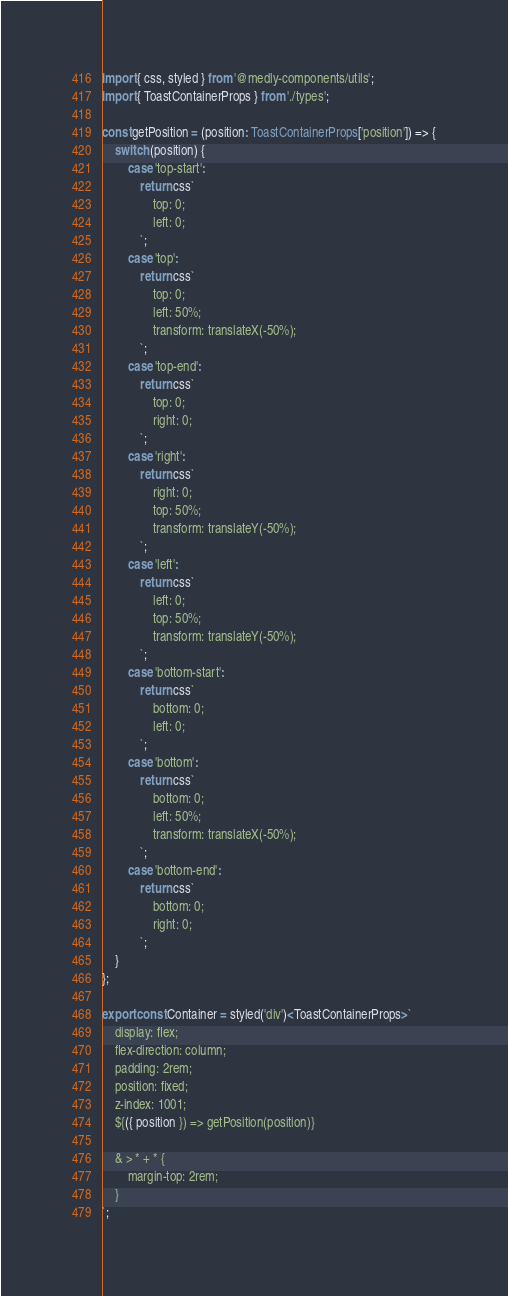<code> <loc_0><loc_0><loc_500><loc_500><_TypeScript_>import { css, styled } from '@medly-components/utils';
import { ToastContainerProps } from './types';

const getPosition = (position: ToastContainerProps['position']) => {
    switch (position) {
        case 'top-start':
            return css`
                top: 0;
                left: 0;
            `;
        case 'top':
            return css`
                top: 0;
                left: 50%;
                transform: translateX(-50%);
            `;
        case 'top-end':
            return css`
                top: 0;
                right: 0;
            `;
        case 'right':
            return css`
                right: 0;
                top: 50%;
                transform: translateY(-50%);
            `;
        case 'left':
            return css`
                left: 0;
                top: 50%;
                transform: translateY(-50%);
            `;
        case 'bottom-start':
            return css`
                bottom: 0;
                left: 0;
            `;
        case 'bottom':
            return css`
                bottom: 0;
                left: 50%;
                transform: translateX(-50%);
            `;
        case 'bottom-end':
            return css`
                bottom: 0;
                right: 0;
            `;
    }
};

export const Container = styled('div')<ToastContainerProps>`
    display: flex;
    flex-direction: column;
    padding: 2rem;
    position: fixed;
    z-index: 1001;
    ${({ position }) => getPosition(position)}

    & > * + * {
        margin-top: 2rem;
    }
`;
</code> 